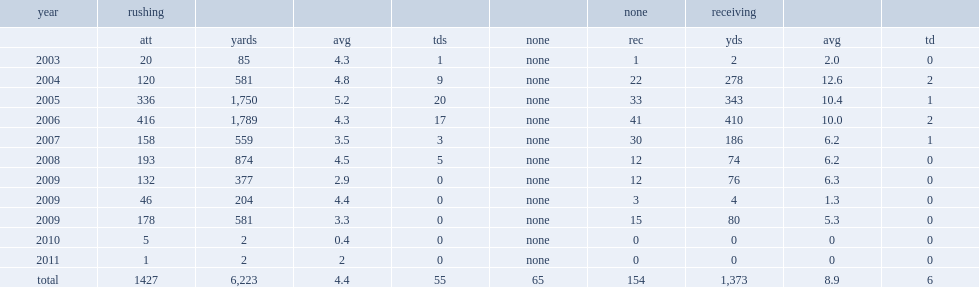How many rushing yards did johnson get in 2005? 1750.0. 